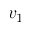<formula> <loc_0><loc_0><loc_500><loc_500>v _ { 1 }</formula> 